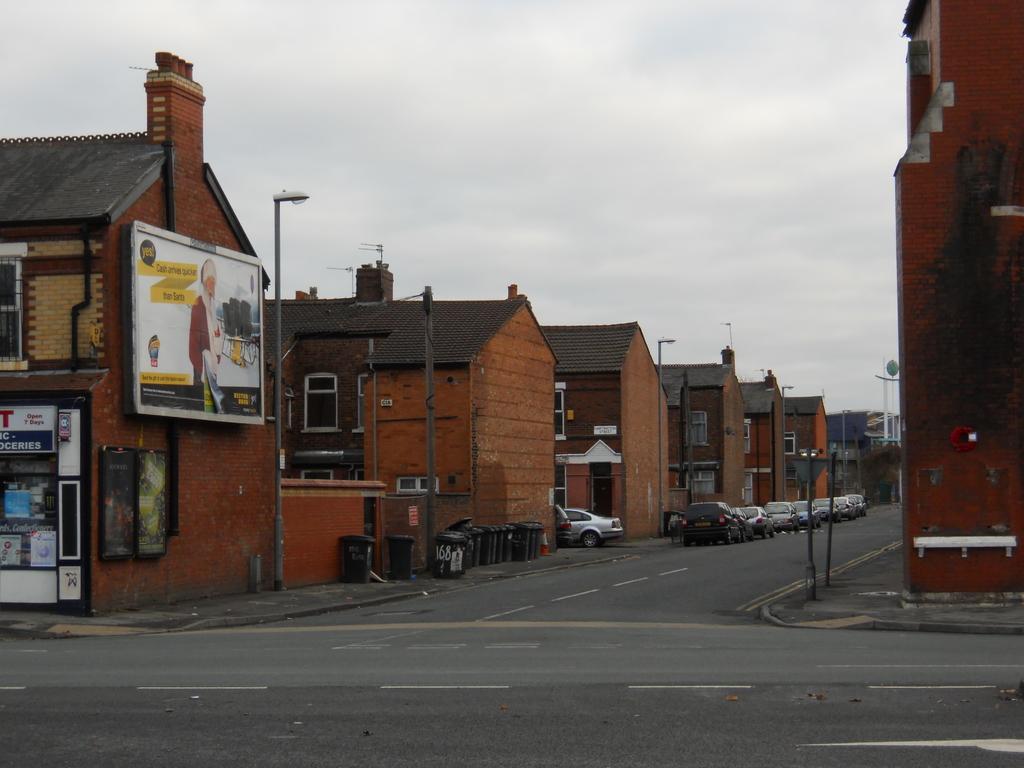How would you summarize this image in a sentence or two? In this image on the right side there is a building wall, two poles visible in front of the wall, in the middle there are buildings , in front of buildings there is a road, on which there are vehicles, poles, containers, stopper kept in front of the wall, at the top there is the sky, on the left side there is a building , on which there is a board , on the board there is a person image and text. At the bottom there is a road. 